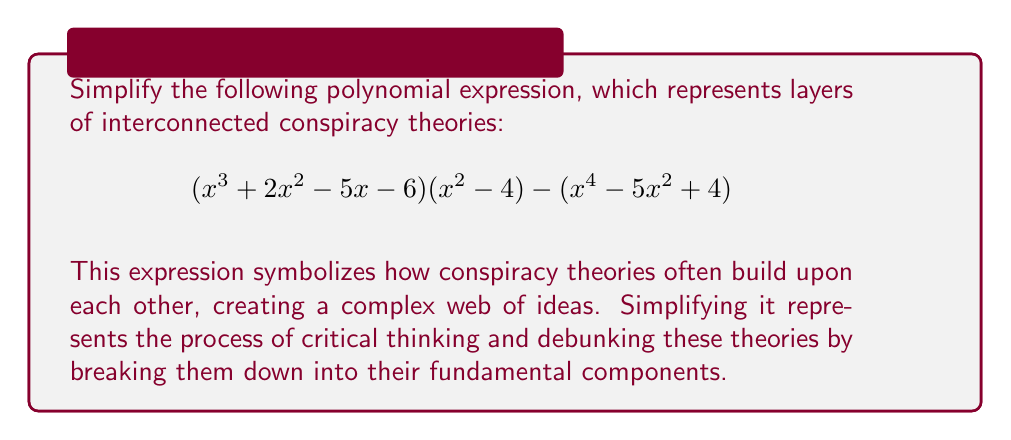Could you help me with this problem? Let's approach this step-by-step:

1) First, let's expand $(x^3 + 2x^2 - 5x - 6)(x^2 - 4)$:
   $$(x^3 + 2x^2 - 5x - 6)(x^2 - 4) = x^5 + 2x^4 - 5x^3 - 6x^2 - 4x^3 - 8x^2 + 20x + 24$$
   $$= x^5 + 2x^4 - 9x^3 - 14x^2 + 20x + 24$$

2) Now our expression looks like:
   $$(x^5 + 2x^4 - 9x^3 - 14x^2 + 20x + 24) - (x^4 - 5x^2 + 4)$$

3) We can subtract the second polynomial from the first:
   $$x^5 + 2x^4 - 9x^3 - 14x^2 + 20x + 24 - x^4 + 5x^2 - 4$$

4) Combining like terms:
   $$x^5 + x^4 - 9x^3 - 9x^2 + 20x + 20$$

5) This is our simplified polynomial. It can't be factored further.

This process symbolizes how, when we critically examine conspiracy theories, we can often simplify them and see that they are less complex than they initially appeared. The resulting polynomial, while still having multiple terms, is simpler and more manageable than the original expression.
Answer: $$x^5 + x^4 - 9x^3 - 9x^2 + 20x + 20$$ 